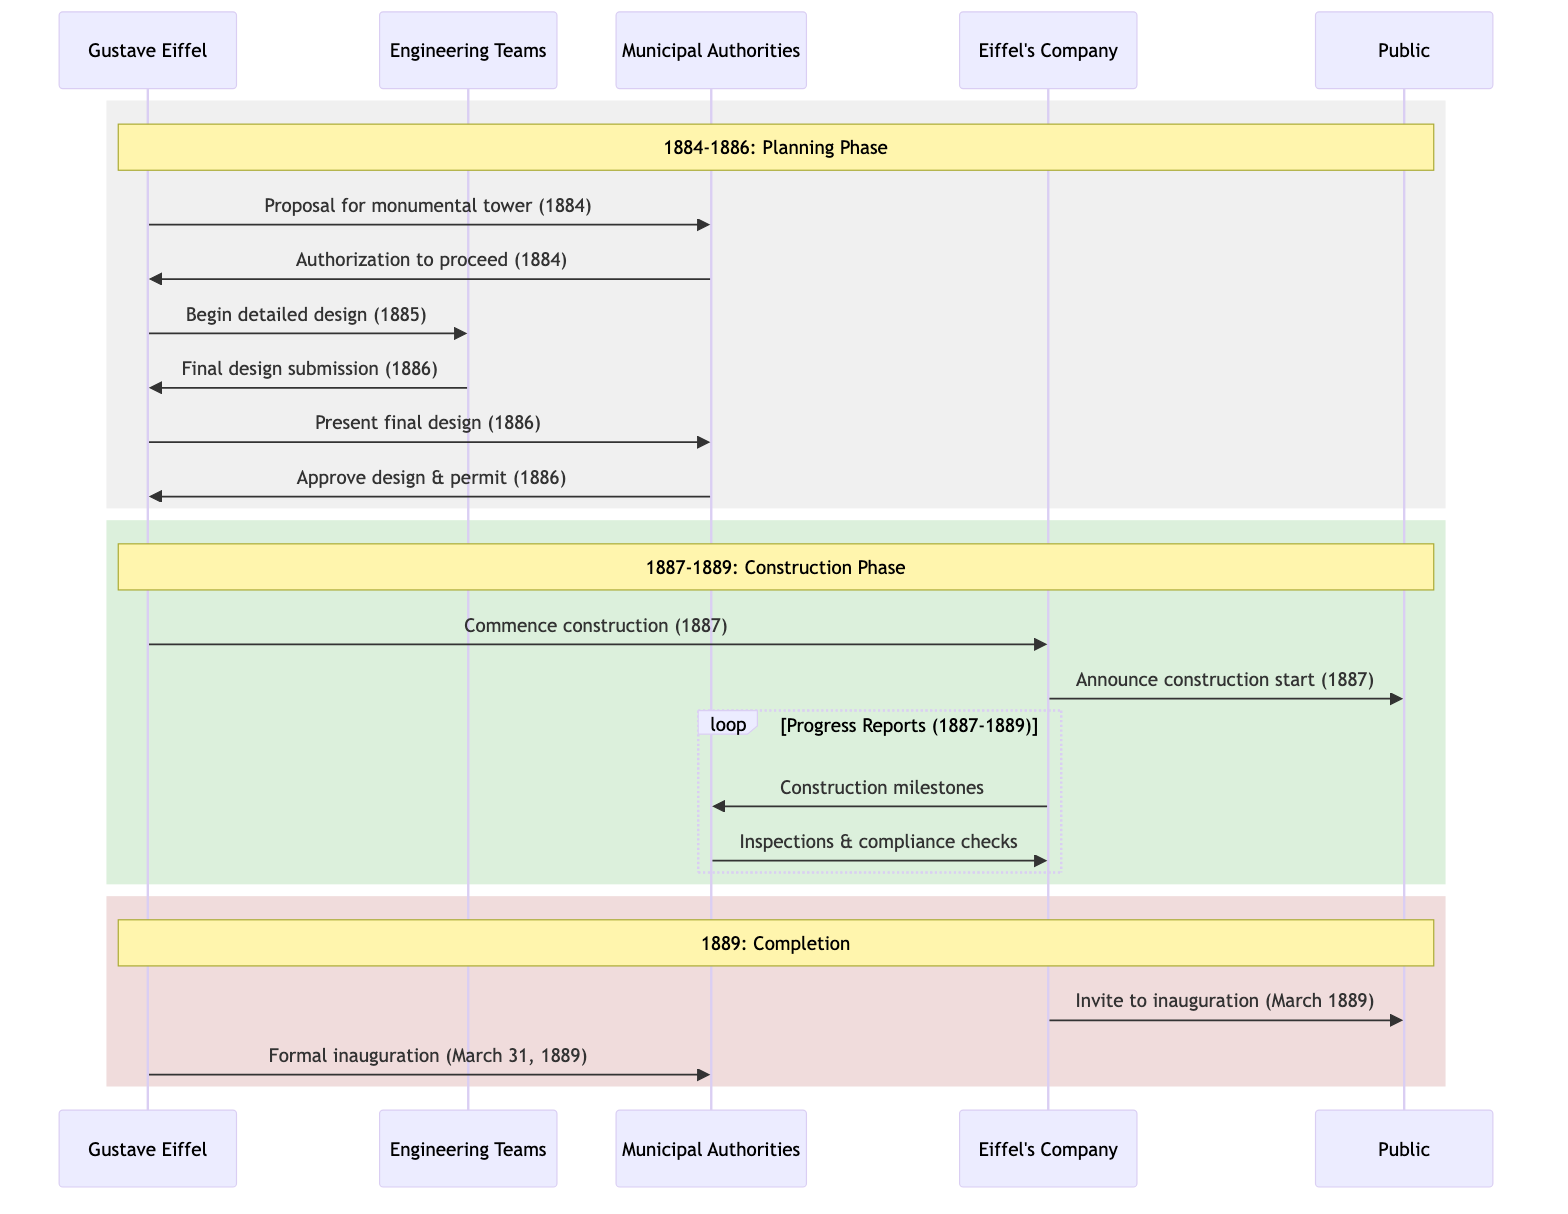What year did Gustave Eiffel propose the construction of the tower? The diagram shows that Gustave Eiffel proposed the construction of the monumental tower to the Municipal Authorities in 1884.
Answer: 1884 What was the response of the Municipal Authorities to Eiffel's proposal in 1884? According to the diagram, the Municipal Authorities provided authorization to proceed with initial designs and studies in response to Eiffel's proposal in the same year, 1884.
Answer: Authorization to proceed How many years did the construction phase last? The construction phase began in 1887 and was completed by March 1889, indicating it lasted for 2 years.
Answer: 2 years Who received the final design submission from the Engineering Teams? The diagram indicates that the final design submission was directed from the Engineering Teams to Gustave Eiffel in 1886.
Answer: Gustave Eiffel What type of reports did Eiffel's Company provide to the Municipal Authorities during construction? The diagram specifies that Eiffel's Company provided progress reports on construction milestones to the Municipal Authorities during the construction period from 1887 to 1889.
Answer: Progress reports What significant event occurred on March 31, 1889? The diagram shows that on March 31, 1889, Gustave Eiffel sent a formal inauguration message to the Municipal Authorities, marking the completion of the Eiffel Tower.
Answer: Formal inauguration What interaction occurred between the Municipal Authorities and Eiffel's Company from 1887 to 1889? The sequence diagram demonstrates that the Municipal Authorities conducted periodic inspections and compliance checks on Eiffel's Company from 1887 to 1889 as part of the oversight process during construction.
Answer: Inspections & compliance checks In which year did Gustave Eiffel give instructions to the Engineering Teams to begin detailed designs? The timeline in the diagram indicates that Gustave Eiffel instructed the Engineering Teams to begin detailed design work in 1885.
Answer: 1885 What was the public informed about in 1887? The diagram states that in 1887, Eiffel's Company announced the start of construction to the Public, signaling the commencement of the project after approvals were in place.
Answer: Announcement of the start of construction 